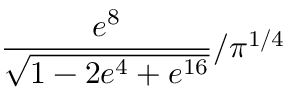<formula> <loc_0><loc_0><loc_500><loc_500>\frac { e ^ { 8 } } { \sqrt { 1 - 2 e ^ { 4 } + e ^ { 1 6 } } } / \pi ^ { 1 / 4 }</formula> 